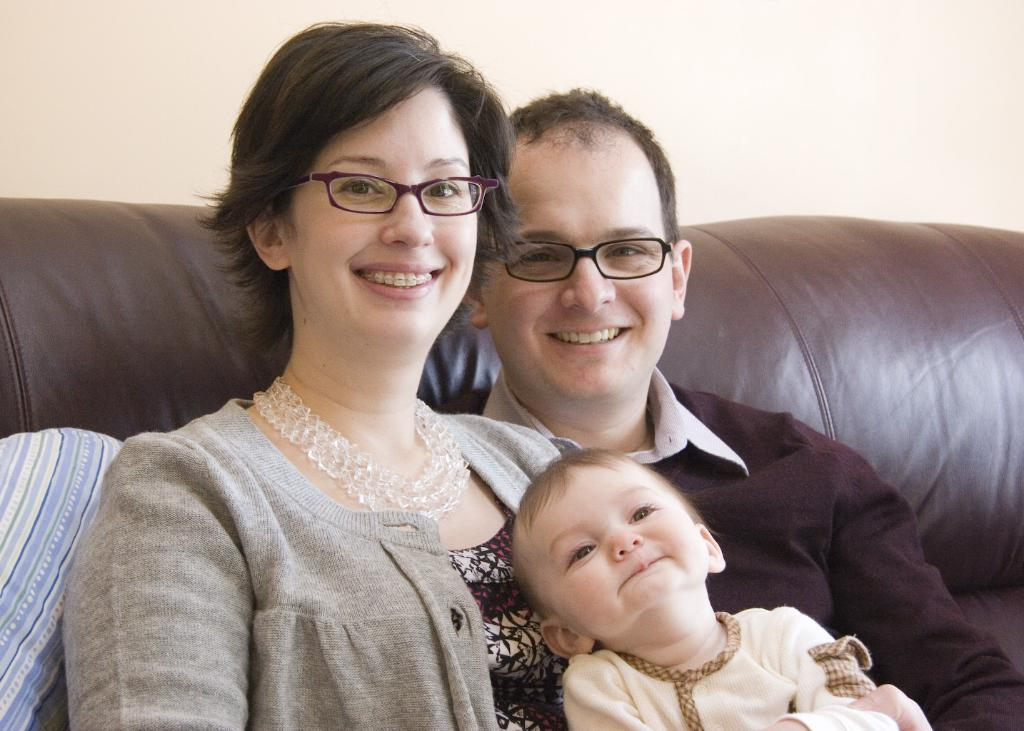How many people are in the image? There are three people in the image: a man, a woman, and a kid. What are the man and woman doing in the image? The man and woman are both smiling in the image. What can be observed about the man and woman's appearance? They are both wearing spectacles. Where are the man and woman seated in the image? They are seated on a sofa. What type of pain is the kid experiencing in the image? There is no indication of pain in the image; the kid is not shown to be in any discomfort. 